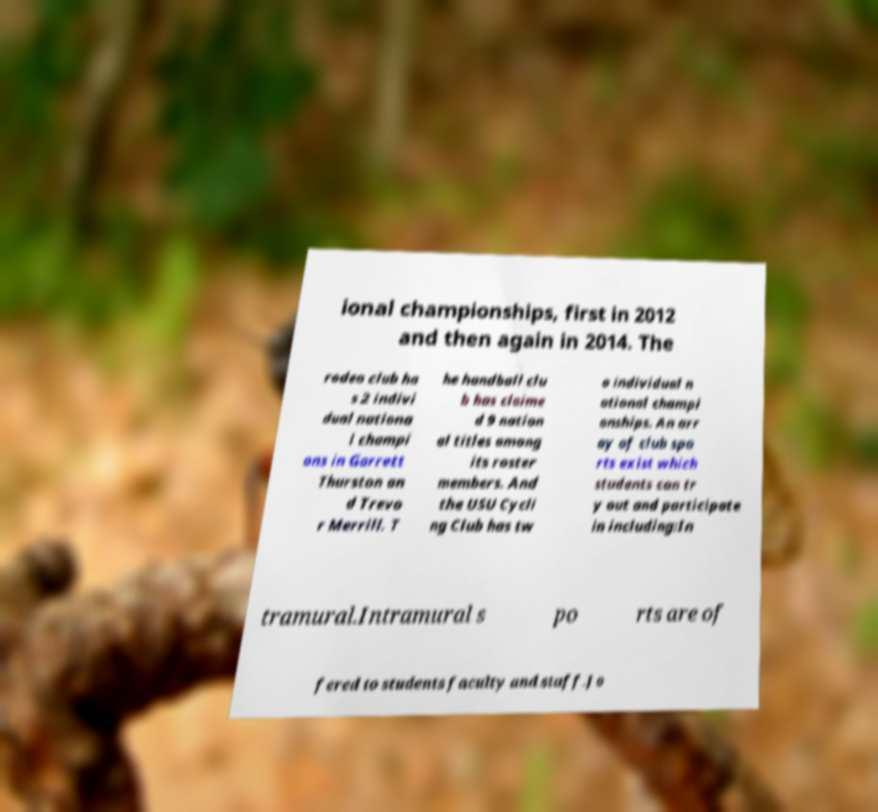There's text embedded in this image that I need extracted. Can you transcribe it verbatim? ional championships, first in 2012 and then again in 2014. The rodeo club ha s 2 indivi dual nationa l champi ons in Garrett Thurston an d Trevo r Merrill. T he handball clu b has claime d 9 nation al titles among its roster members. And the USU Cycli ng Club has tw o individual n ational champi onships. An arr ay of club spo rts exist which students can tr y out and participate in including:In tramural.Intramural s po rts are of fered to students faculty and staff.Jo 